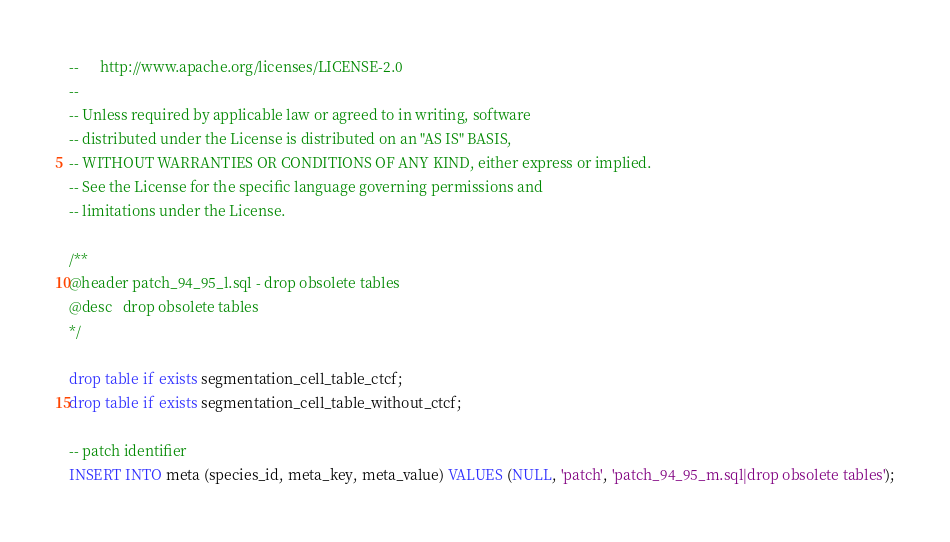<code> <loc_0><loc_0><loc_500><loc_500><_SQL_>--      http://www.apache.org/licenses/LICENSE-2.0
--
-- Unless required by applicable law or agreed to in writing, software
-- distributed under the License is distributed on an "AS IS" BASIS,
-- WITHOUT WARRANTIES OR CONDITIONS OF ANY KIND, either express or implied.
-- See the License for the specific language governing permissions and
-- limitations under the License.

/**
@header patch_94_95_l.sql - drop obsolete tables
@desc   drop obsolete tables
*/

drop table if exists segmentation_cell_table_ctcf;
drop table if exists segmentation_cell_table_without_ctcf;

-- patch identifier
INSERT INTO meta (species_id, meta_key, meta_value) VALUES (NULL, 'patch', 'patch_94_95_m.sql|drop obsolete tables');
</code> 